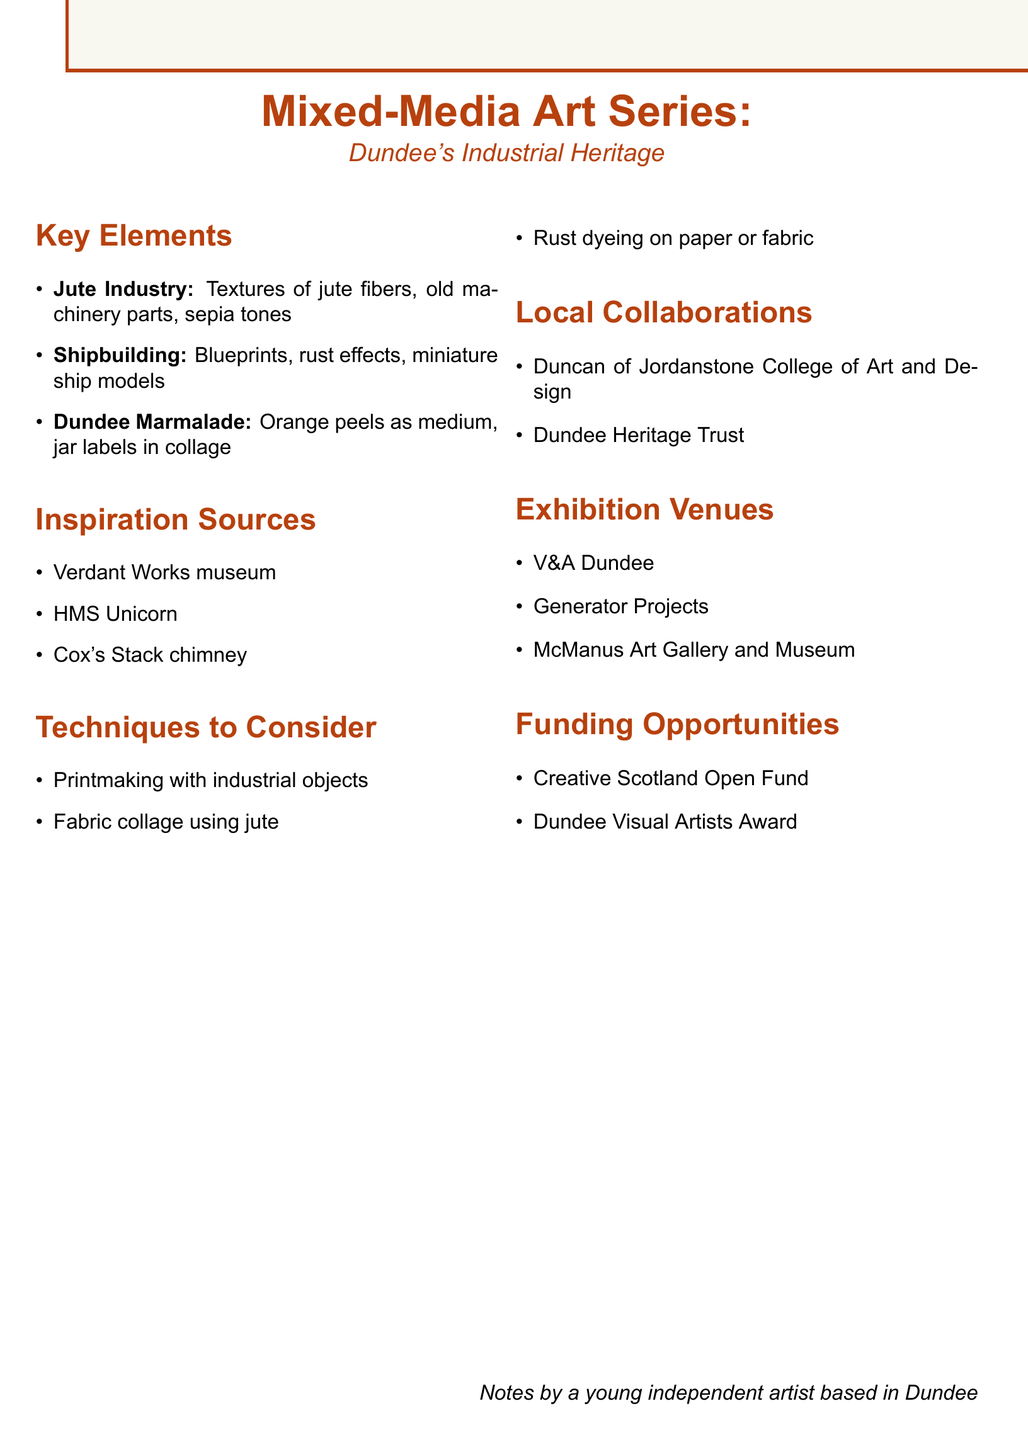What is the focus of the art series? The focus of the art series is on Dundee's industrial heritage, as indicated in the title.
Answer: Dundee's industrial heritage Which industry is highlighted for using jute fibers? The key element specifically mentions the jute industry and its textures.
Answer: Jute Industry Name one source of inspiration for the series. The document lists several sources of inspiration for the art series.
Answer: Verdant Works museum What technique involves using old machinery objects? The technique of printmaking is described as using industrial objects.
Answer: Printmaking with industrial objects Which venue is mentioned as a potential exhibition site? The document lists several venues where the art series could be exhibited.
Answer: V&A Dundee What collaboration is suggested with a local college? The document specifies collaboration with Duncan of Jordanstone College of Art and Design.
Answer: Duncan of Jordanstone College of Art and Design How many funding opportunities are listed? Two funding opportunities are separately listed in the document.
Answer: 2 What medium is suggested to experiment with for the Dundee Marmalade element? The detail about Dundee Marmalade mentions using orange peels as a medium.
Answer: Orange peels Include one type of dyeing technique mentioned. The document lists rust dyeing as one of the techniques to consider.
Answer: Rust dyeing 